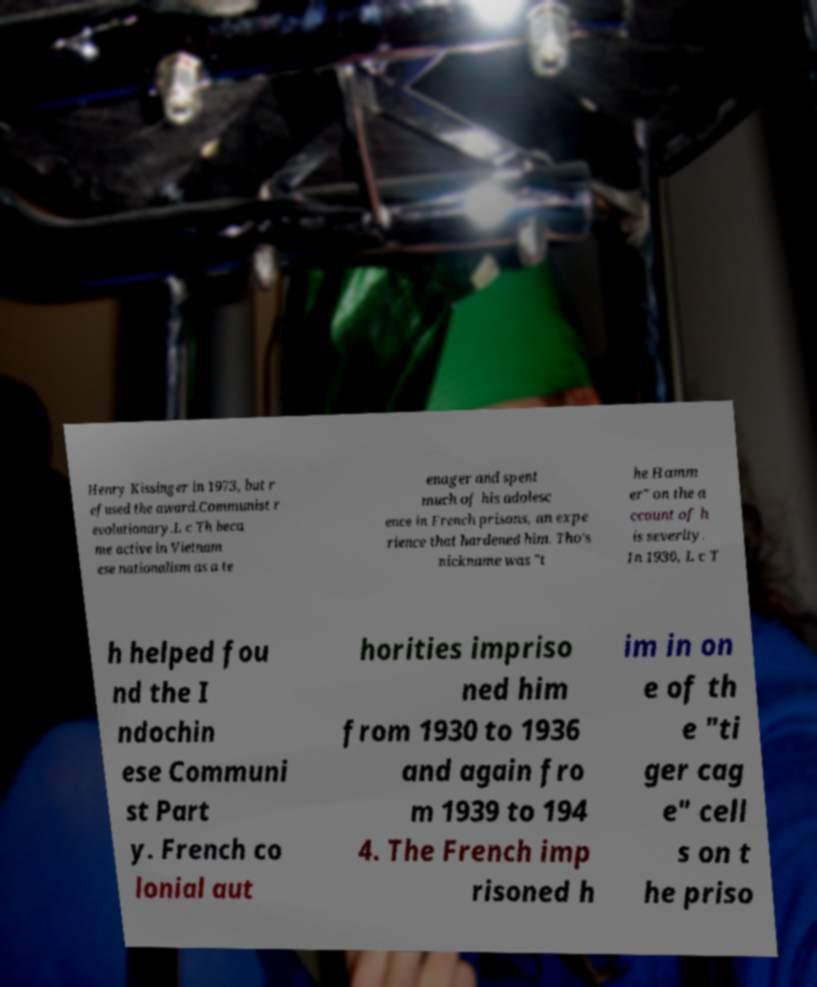I need the written content from this picture converted into text. Can you do that? Henry Kissinger in 1973, but r efused the award.Communist r evolutionary.L c Th beca me active in Vietnam ese nationalism as a te enager and spent much of his adolesc ence in French prisons, an expe rience that hardened him. Tho's nickname was "t he Hamm er" on the a ccount of h is severity. In 1930, L c T h helped fou nd the I ndochin ese Communi st Part y. French co lonial aut horities impriso ned him from 1930 to 1936 and again fro m 1939 to 194 4. The French imp risoned h im in on e of th e "ti ger cag e" cell s on t he priso 